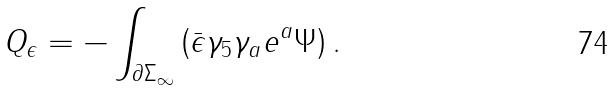<formula> <loc_0><loc_0><loc_500><loc_500>Q _ { \epsilon } = - \int _ { \partial \Sigma _ { \infty } } \left ( \bar { \epsilon } \gamma _ { 5 } \gamma _ { a } e ^ { a } \Psi \right ) .</formula> 